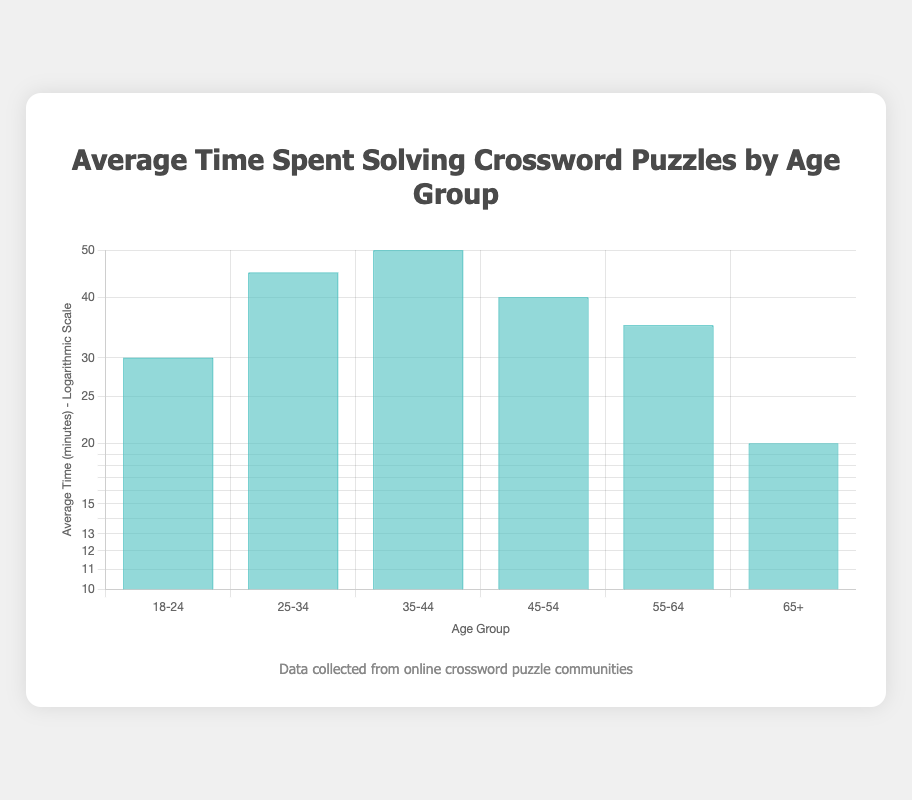What is the average time spent solving puzzles by the age group 25-34? The data directly indicates that for the age group 25-34, the average time spent solving puzzles is 45 minutes.
Answer: 45 minutes Which age group spends the least amount of time solving puzzles? From the data, the age group 65+ has the lowest average time, which is 20 minutes, compared to other age groups.
Answer: 65+ What is the difference in average time between the age groups 35-44 and 45-54? The average time for group 35-44 is 50 minutes and for 45-54 is 40 minutes. The difference is calculated as 50 - 40 = 10 minutes.
Answer: 10 minutes Is it true that the age group 18-24 spends more time solving puzzles than the age group 55-64? According to the data, the average time for 18-24 is 30 minutes, while for 55-64 it is 35 minutes. Therefore, the statement is false.
Answer: No What is the total average time spent solving puzzles by all age groups combined? To find the total, sum the average times for each age group: 30 + 45 + 50 + 40 + 35 + 20 = 220 minutes; then divide by the number of age groups, which is 6. Therefore, the average is 220 / 6 = approximately 36.67 minutes.
Answer: 36.67 minutes Which age group has the highest average time, and what is that time? From the table, the age group 35-44 has the highest average time of 50 minutes.
Answer: 35-44, 50 minutes If the average time of the age group 65+ were increased by 10 minutes, how would it compare to the age group 55-64? Currently, the average time for 65+ is 20 minutes. If increased by 10 minutes, it becomes 30 minutes. The average for 55-64 is 35 minutes. Since 30 is less than 35, the adjusted 65+ time would still be lower.
Answer: It would still be lower What is the overall trend in average time spent solving puzzles as age increases? Analyzing the data shows that average time spent generally increases until the age group 35-44, then decreases for age groups 45-54 and 65+, indicating a peak at 35-44 years old followed by a decline.
Answer: Peaks at 35-44, decreases thereafter 